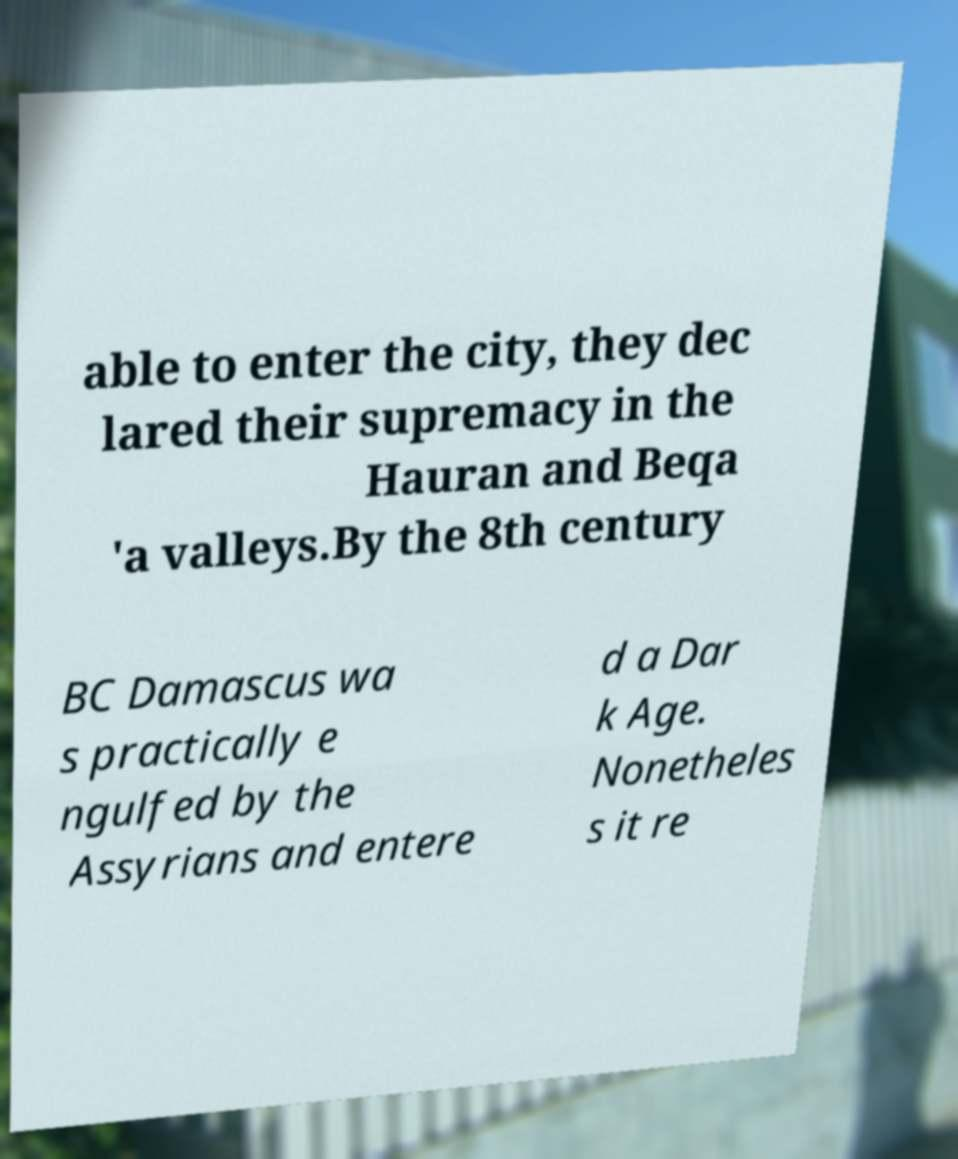I need the written content from this picture converted into text. Can you do that? able to enter the city, they dec lared their supremacy in the Hauran and Beqa 'a valleys.By the 8th century BC Damascus wa s practically e ngulfed by the Assyrians and entere d a Dar k Age. Nonetheles s it re 